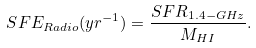<formula> <loc_0><loc_0><loc_500><loc_500>S F E _ { R a d i o } ( y r ^ { - 1 } ) = \frac { S F R _ { 1 . 4 - G H z } } { M _ { H I } } .</formula> 